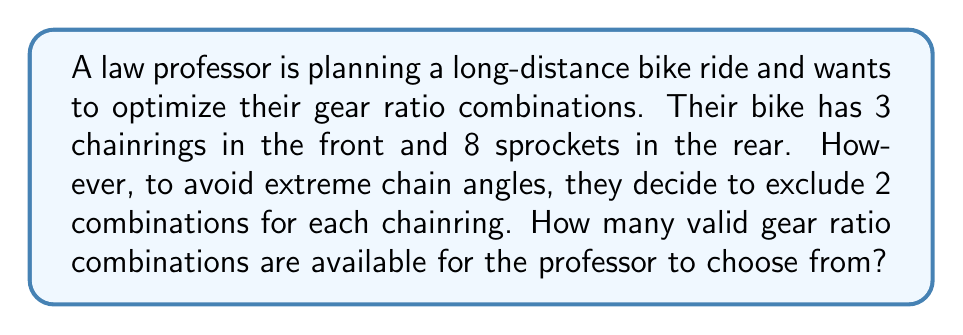Could you help me with this problem? Let's approach this step-by-step:

1. First, we need to calculate the total number of possible combinations without any restrictions:
   $$ \text{Total combinations} = 3 \times 8 = 24 $$

2. Now, we need to subtract the excluded combinations:
   - There are 3 chainrings
   - For each chainring, 2 combinations are excluded
   - So, the total number of excluded combinations is:
     $$ \text{Excluded combinations} = 3 \times 2 = 6 $$

3. To find the number of valid combinations, we subtract the excluded combinations from the total:
   $$ \text{Valid combinations} = \text{Total combinations} - \text{Excluded combinations} $$
   $$ \text{Valid combinations} = 24 - 6 = 18 $$

Therefore, the law professor has 18 valid gear ratio combinations to choose from for optimal performance during their bike ride.
Answer: 18 